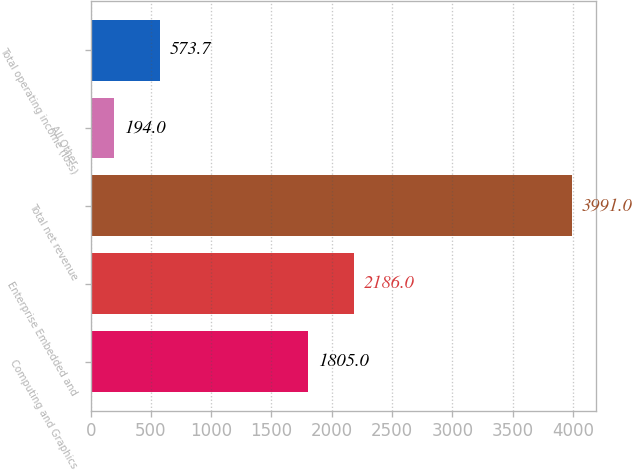<chart> <loc_0><loc_0><loc_500><loc_500><bar_chart><fcel>Computing and Graphics<fcel>Enterprise Embedded and<fcel>Total net revenue<fcel>All Other<fcel>Total operating income (loss)<nl><fcel>1805<fcel>2186<fcel>3991<fcel>194<fcel>573.7<nl></chart> 